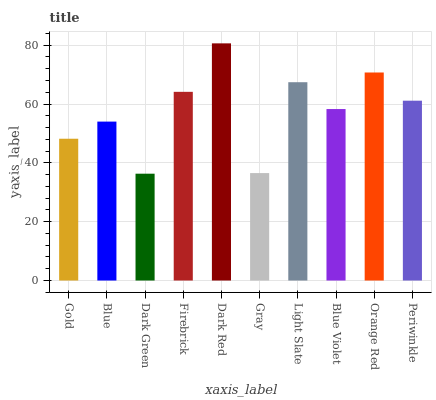Is Blue the minimum?
Answer yes or no. No. Is Blue the maximum?
Answer yes or no. No. Is Blue greater than Gold?
Answer yes or no. Yes. Is Gold less than Blue?
Answer yes or no. Yes. Is Gold greater than Blue?
Answer yes or no. No. Is Blue less than Gold?
Answer yes or no. No. Is Periwinkle the high median?
Answer yes or no. Yes. Is Blue Violet the low median?
Answer yes or no. Yes. Is Dark Green the high median?
Answer yes or no. No. Is Periwinkle the low median?
Answer yes or no. No. 